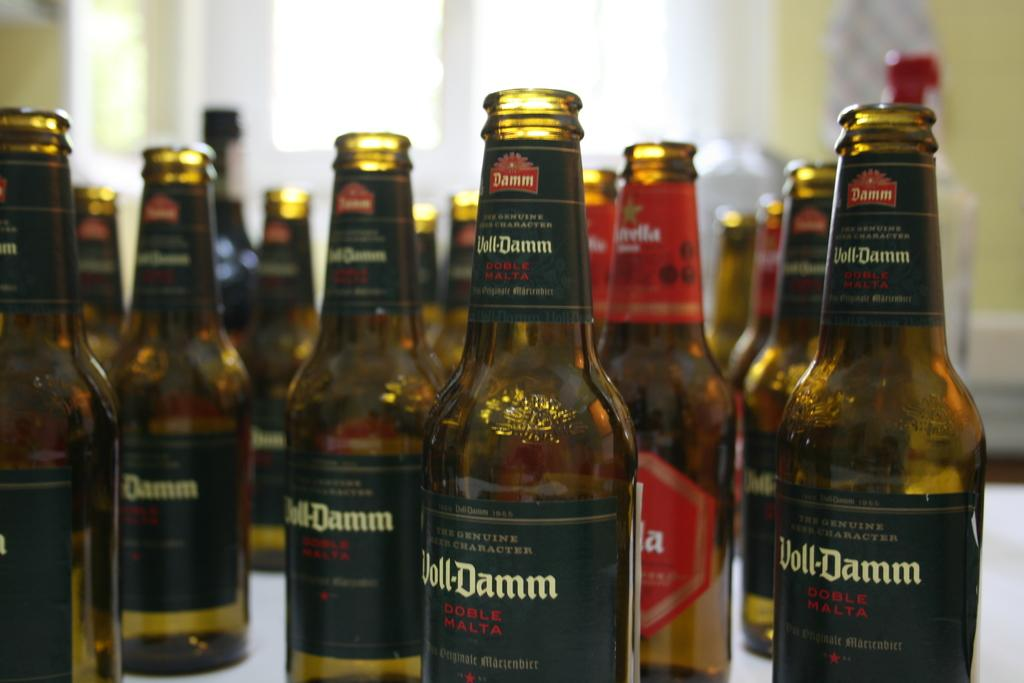<image>
Write a terse but informative summary of the picture. Many bottles of Doll-Damm next to one another. 